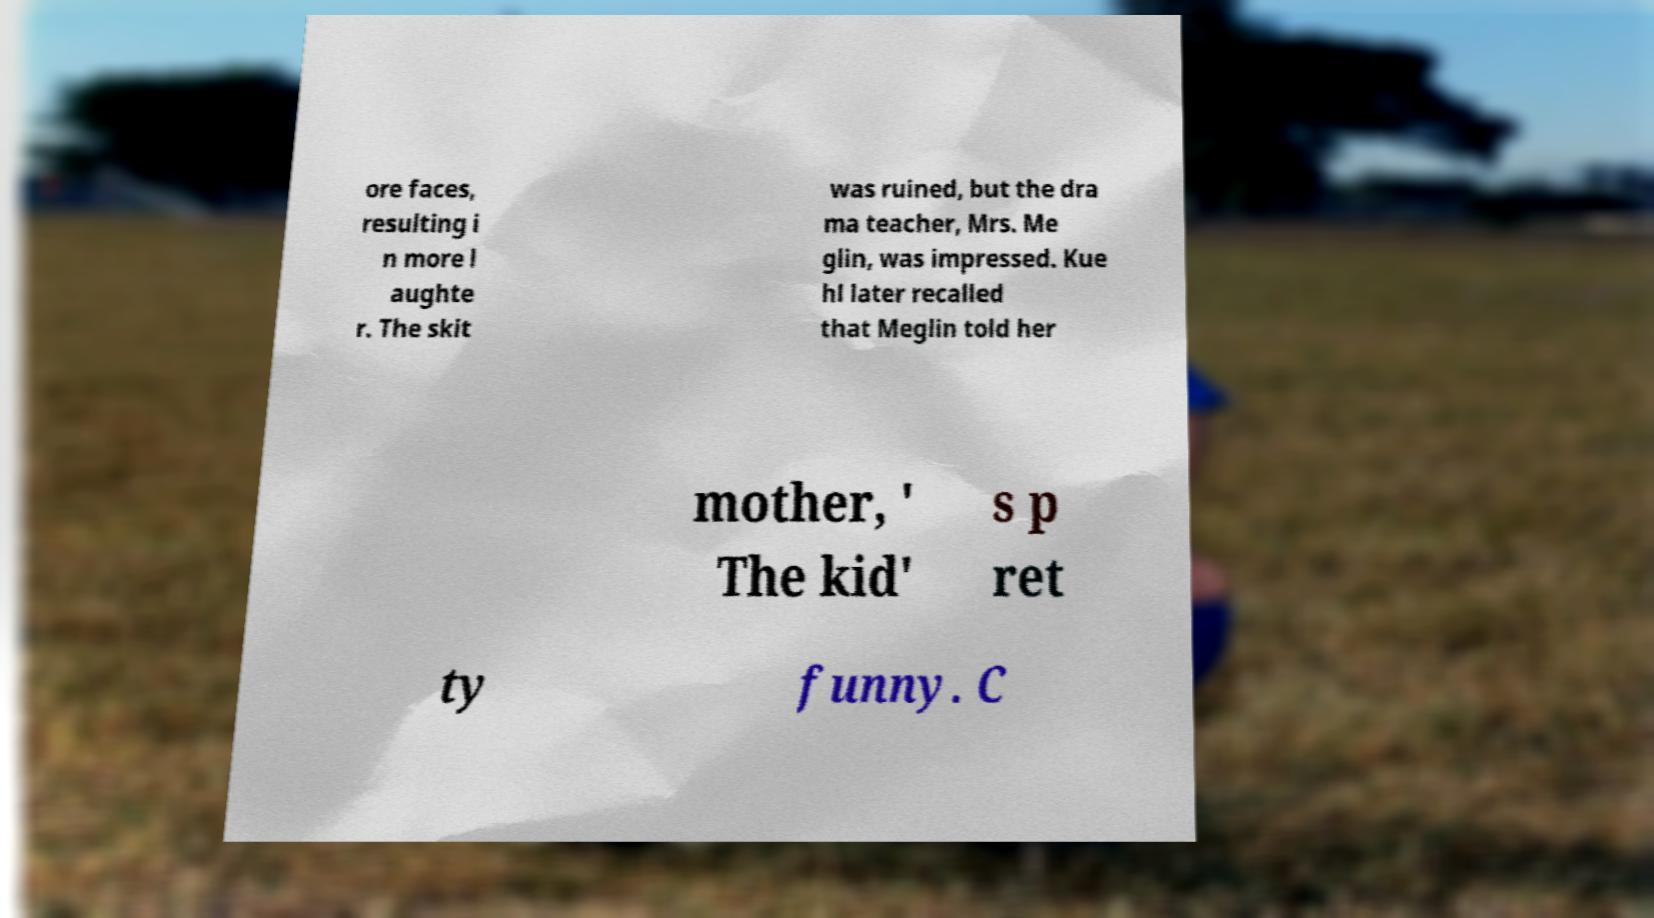Can you accurately transcribe the text from the provided image for me? ore faces, resulting i n more l aughte r. The skit was ruined, but the dra ma teacher, Mrs. Me glin, was impressed. Kue hl later recalled that Meglin told her mother, ' The kid' s p ret ty funny. C 